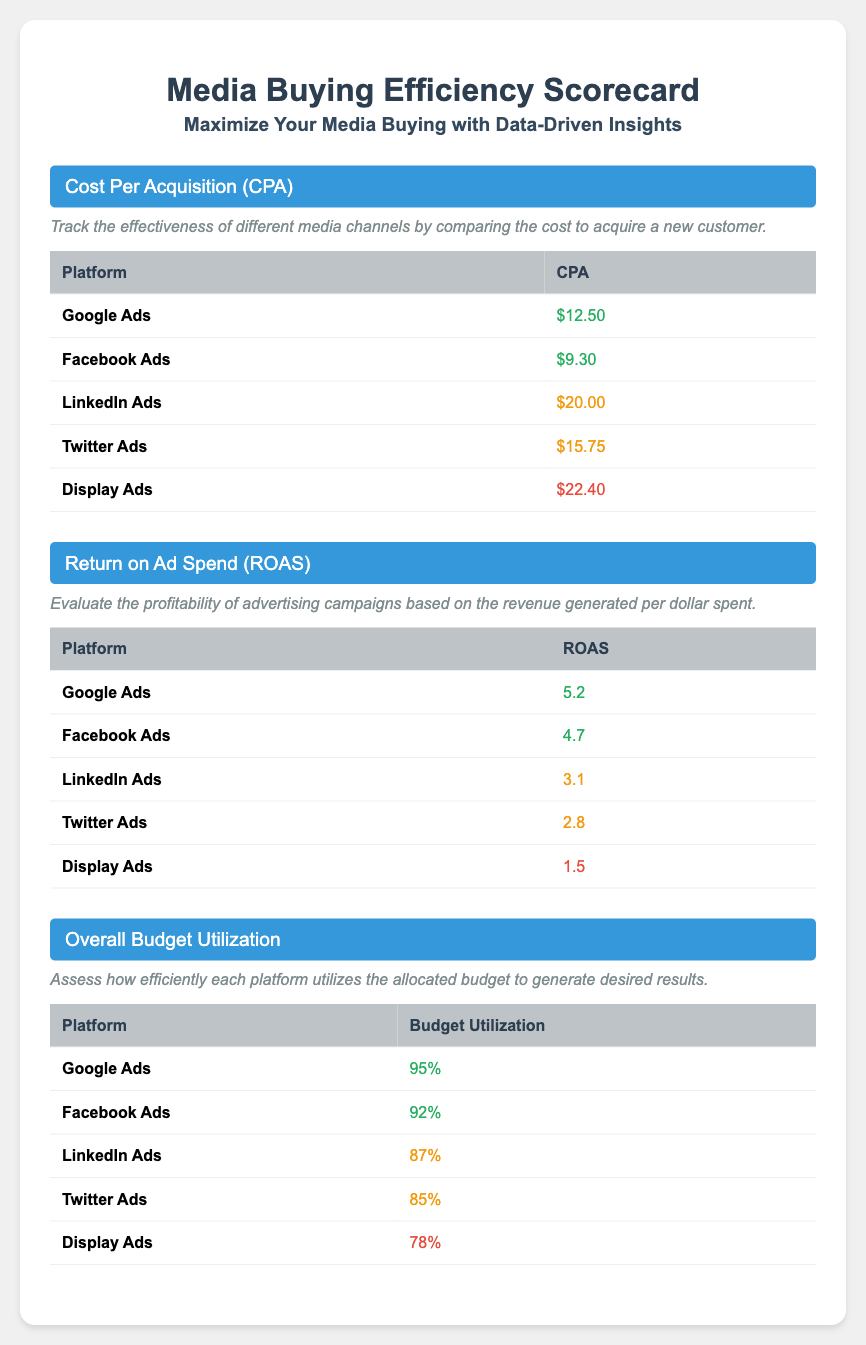What is the CPA for Facebook Ads? The document states the CPA for Facebook Ads is $9.30.
Answer: $9.30 Which platform has the highest ROAS? The highest ROAS in the document is for Google Ads, which is 5.2.
Answer: 5.2 What is the Budget Utilization percentage for Display Ads? The document indicates that the Budget Utilization for Display Ads is 78%.
Answer: 78% Which platform has the lowest CPA? The lowest CPA is for Facebook Ads at $9.30.
Answer: $9.30 How does Google Ads rank in terms of Budget Utilization? Google Ads has the highest Budget Utilization at 95%.
Answer: 95% What is the ROAS for LinkedIn Ads? The document shows that the ROAS for LinkedIn Ads is 3.1.
Answer: 3.1 What color indicates a poor Budget Utilization? The document uses red to indicate poor Budget Utilization.
Answer: Red Which platform has a CPA that falls in the yellow category? The platforms with a yellow CPA are LinkedIn Ads and Twitter Ads.
Answer: LinkedIn Ads, Twitter Ads 